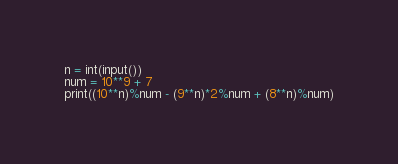<code> <loc_0><loc_0><loc_500><loc_500><_Python_>n = int(input())
num = 10**9 + 7
print((10**n)%num - (9**n)*2%num + (8**n)%num)</code> 